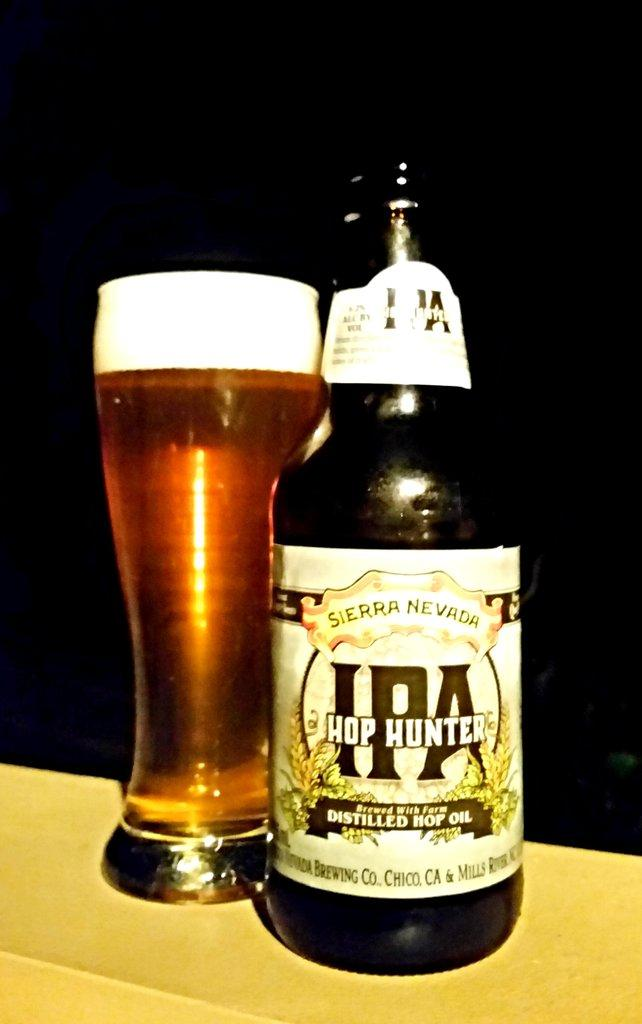<image>
Offer a succinct explanation of the picture presented. A bottle of Hop Hunter sitting beside a full glass. 